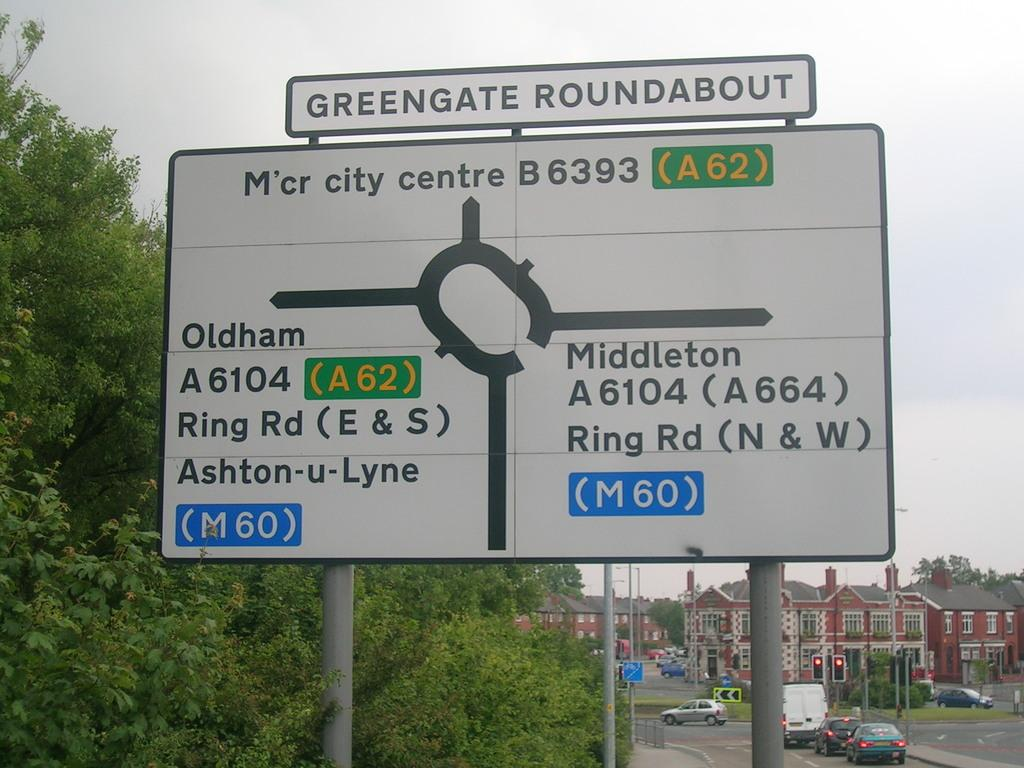Provide a one-sentence caption for the provided image. A street sign shows the exits off of the Greengate Roundabout. 